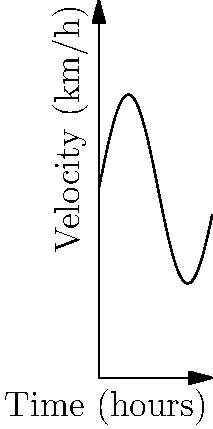As a Worthington local who relies on cycling, you're planning a trip to a nearby town. The velocity of your bicycle (in km/h) as a function of time (in hours) is given by $v(t) = 10 + 5\sin(t)$, where $t$ is measured from the start of your journey. Calculate the total distance traveled after 6 hours. To find the total distance traveled, we need to integrate the velocity function over the given time interval. Here's how we proceed:

1) The distance traveled is given by the integral of velocity with respect to time:
   $$d = \int_0^6 v(t) dt$$

2) Substituting the given velocity function:
   $$d = \int_0^6 (10 + 5\sin(t)) dt$$

3) We can split this into two integrals:
   $$d = \int_0^6 10 dt + \int_0^6 5\sin(t) dt$$

4) Evaluating the first integral:
   $$\int_0^6 10 dt = 10t \bigg|_0^6 = 60$$

5) For the second integral:
   $$\int_0^6 5\sin(t) dt = -5\cos(t) \bigg|_0^6 = -5(\cos(6) - \cos(0)) = -5(\cos(6) - 1)$$

6) Combining the results:
   $$d = 60 - 5(\cos(6) - 1) = 60 - 5\cos(6) + 5 = 65 - 5\cos(6)$$

7) Using a calculator or computer to evaluate $\cos(6)$:
   $$d \approx 65 - 5(-0.96) \approx 69.8$$

Therefore, the total distance traveled after 6 hours is approximately 69.8 km.
Answer: 69.8 km 